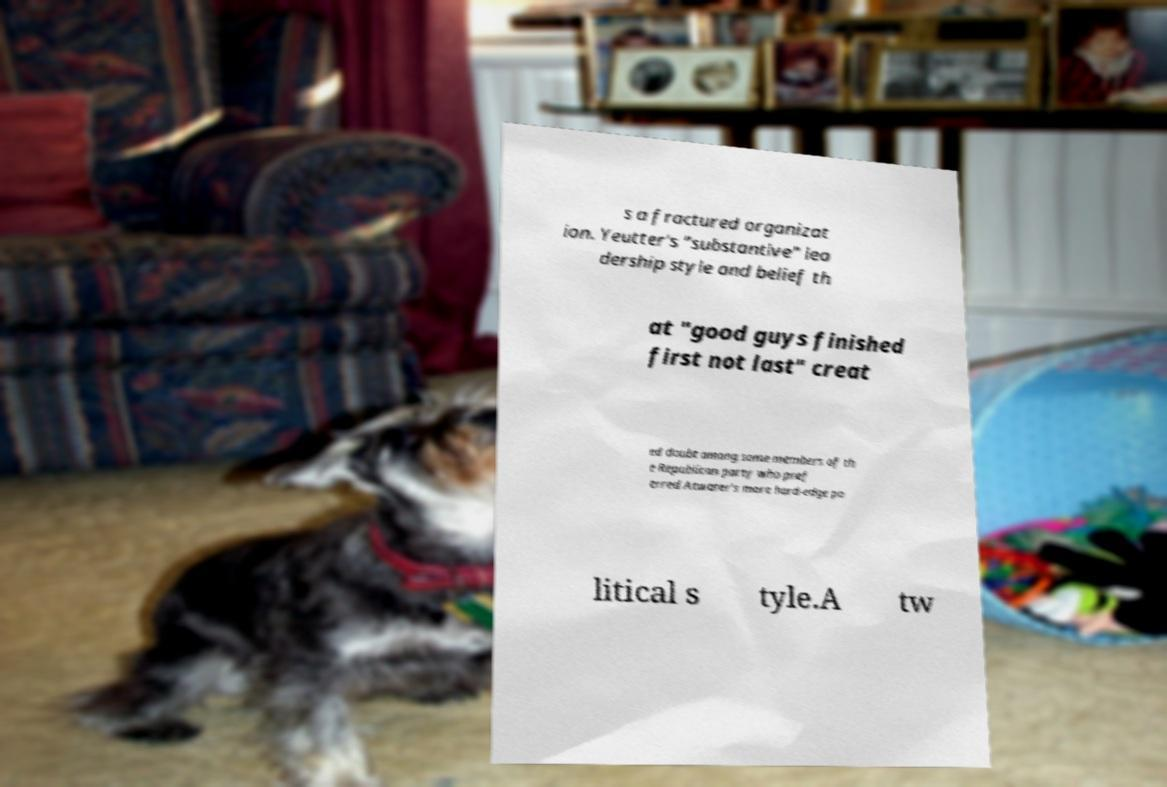Please read and relay the text visible in this image. What does it say? s a fractured organizat ion. Yeutter's "substantive" lea dership style and belief th at "good guys finished first not last" creat ed doubt among some members of th e Republican party who pref erred Atwater's more hard-edge po litical s tyle.A tw 